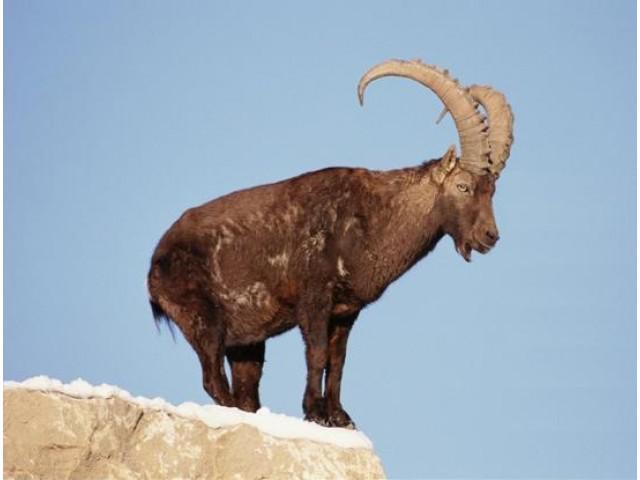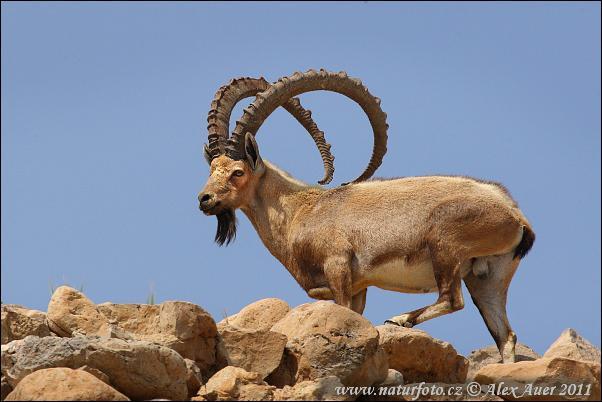The first image is the image on the left, the second image is the image on the right. Considering the images on both sides, is "Exactly one animal is facing to the left." valid? Answer yes or no. Yes. The first image is the image on the left, the second image is the image on the right. Evaluate the accuracy of this statement regarding the images: "The images show a single horned animal, and they face in different [left or right] directions.". Is it true? Answer yes or no. Yes. 